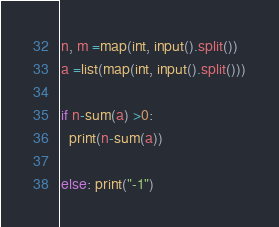<code> <loc_0><loc_0><loc_500><loc_500><_Python_>n, m =map(int, input().split())
a =list(map(int, input().split()))

if n-sum(a) >0:
  print(n-sum(a))

else: print("-1")</code> 